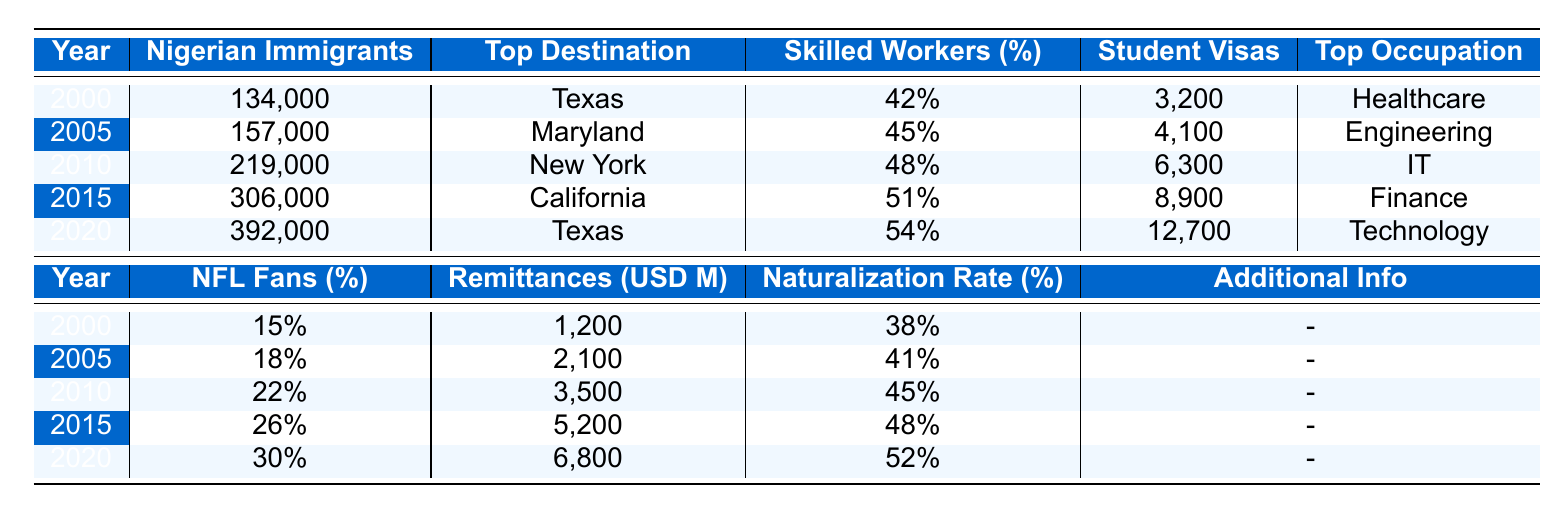What year had the highest number of Nigerian immigrants? The data shows that 2020 had the highest number of Nigerian immigrants, with a total of 392,000.
Answer: 2020 Which state was the top destination for Nigerian immigrants in 2005? According to the table, Maryland was the top destination state for Nigerian immigrants in 2005.
Answer: Maryland What was the percentage of skilled workers among Nigerian immigrants in 2015? The table indicates that 51% of Nigerian immigrants in 2015 were skilled workers.
Answer: 51% What were the total remittances sent to Nigeria by immigrants in 2010? The table shows that in 2010, the remittances sent to Nigeria amounted to 3,500 million USD.
Answer: 3,500 million USD How many student visas were issued to Nigerian immigrants in 2020? The data reveals that in 2020, 12,700 student visas were issued to Nigerian immigrants.
Answer: 12,700 What was the percentage increase in Nigerian immigrants from 2000 to 2020? The number of Nigerian immigrants increased from 134,000 in 2000 to 392,000 in 2020. The percentage increase is calculated as ((392,000 - 134,000) / 134,000) * 100 = 192.54%.
Answer: 192.54% Did the percentage of NFL fans among Nigerian immigrants increase every year from 2000 to 2020? The table shows the percentage of NFL fans increased each year: 15% in 2000, 18% in 2005, 22% in 2010, 26% in 2015, and 30% in 2020. Therefore, it did increase every year.
Answer: Yes Which year had the lowest naturalization rate for Nigerian immigrants? By examining the table, 2000 had the lowest naturalization rate at 38%.
Answer: 2000 What was the top occupation of Nigerian immigrants in 2015? According to the table, the top occupation in 2015 for Nigerian immigrants was Finance.
Answer: Finance Calculate the average percentage of skilled workers from the years 2000 to 2020. The percentages of skilled workers from 2000 to 2020 are 42%, 45%, 48%, 51%, and 54%. Adding them gives 240% and dividing by 5 yields an average of 48%.
Answer: 48% 